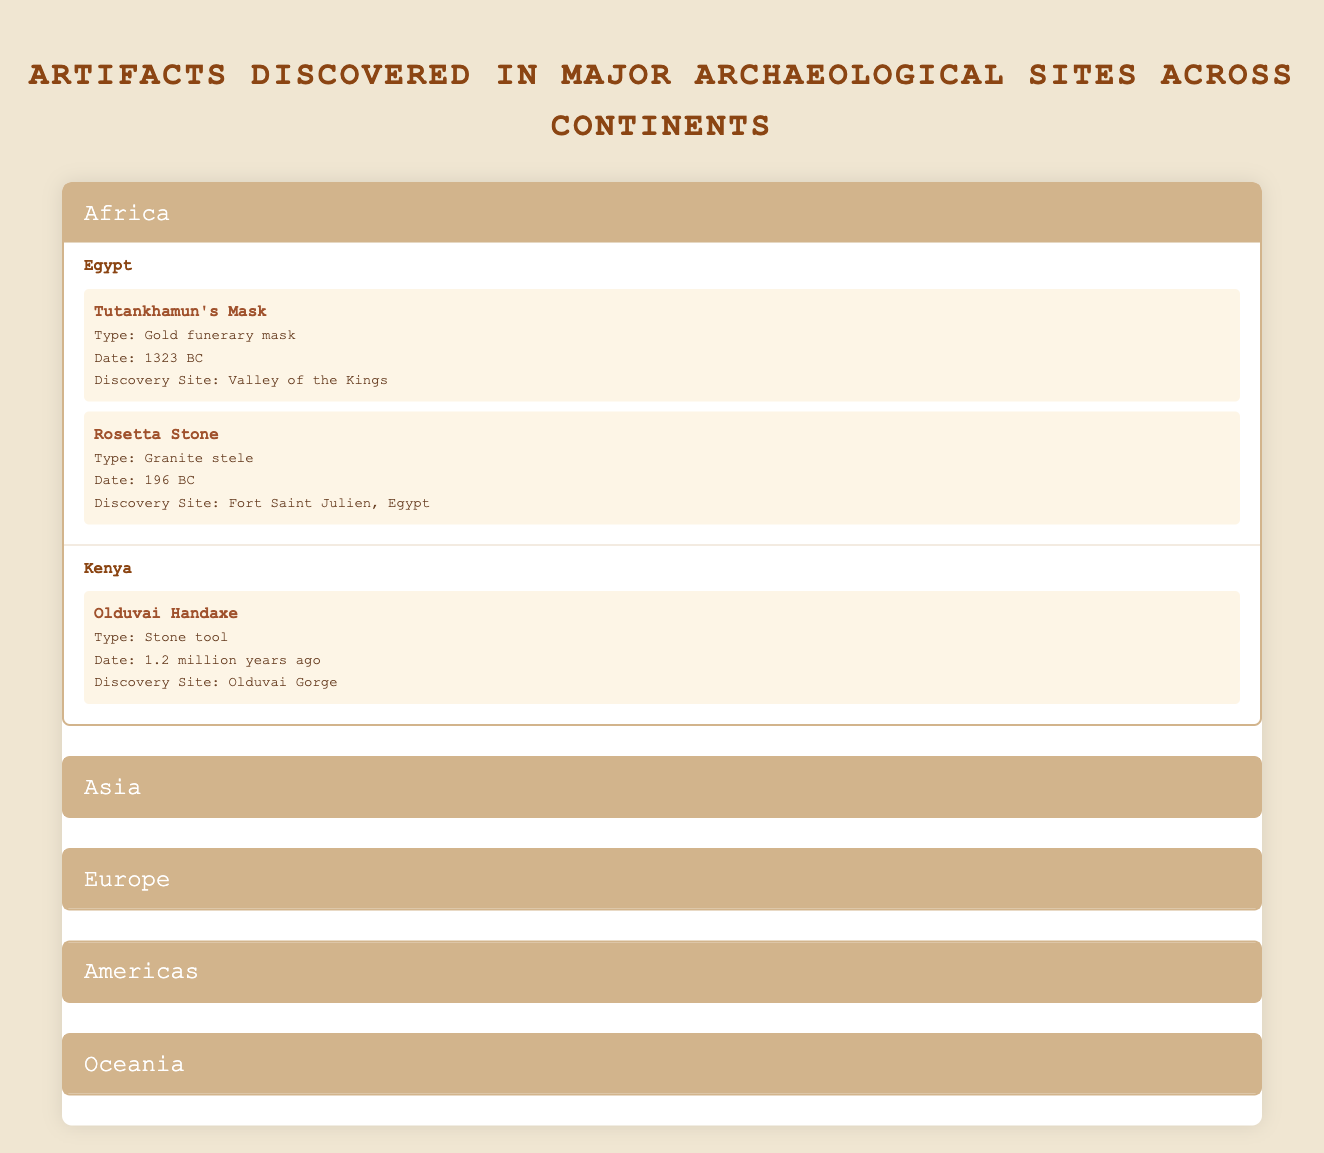What artifact from Egypt was discovered in the Valley of the Kings? The table shows that "Tutankhamun's Mask" is listed as an artifact from Egypt with the discovery site being the Valley of the Kings.
Answer: Tutankhamun's Mask Which continent has an artifact named the "Terracotta Army"? The table indicates that the "Terracotta Army" is an artifact located in China, which is part of the continent Asia.
Answer: Asia How many artifacts were discovered in Peru? The table lists two artifacts under Peru: "Machu Picchu" and "Nazca Lines", so the total number is 2.
Answer: 2 Is the "Olduvai Handaxe" a stone tool? According to the table, the "Olduvai Handaxe" is explicitly categorized as a stone tool, confirming the statement as true.
Answer: Yes Which artifact has the earliest date of discovery, and what is that date? To find the earliest discovery date, we compare the dates of all artifacts. The "Olduvai Handaxe" has a date of "1.2 million years ago," making it the earliest.
Answer: Olduvai Handaxe, 1.2 million years ago How many types of artifacts were discovered in the Americas? The table shows two artifacts in Peru (Incan citadel and Geoglyphs) and one in Mexico (Mesoamerican pyramid), thus the total types are 3.
Answer: 3 Is "Kakadu Rock Art" the only artifact listed for Australia? The table does not list any other artifacts for Australia and shows that "Kakadu Rock Art" is the only one, confirming the statement as true.
Answer: Yes What is the date of the "Dancing Girl of Mohenjo-Daro"? By looking at the table, the date for "Dancing Girl of Mohenjo-Daro" is recorded as "2500 BC".
Answer: 2500 BC Which continent features the most artifacts listed in the table? By analyzing the artifacts listed, Africa has a total of 3 artifacts, Asia has 3, Europe has 3, Americas has 3, but Oceania has 1. Therefore, they are all equal, but a deeper inspection might reveal more artifacts of significance, if any had variation in details. Hence, technically, they have the same count overall.
Answer: All have equal artifacts (3 for Africa, Asia, Europe, and Americas; 1 for Oceania) 